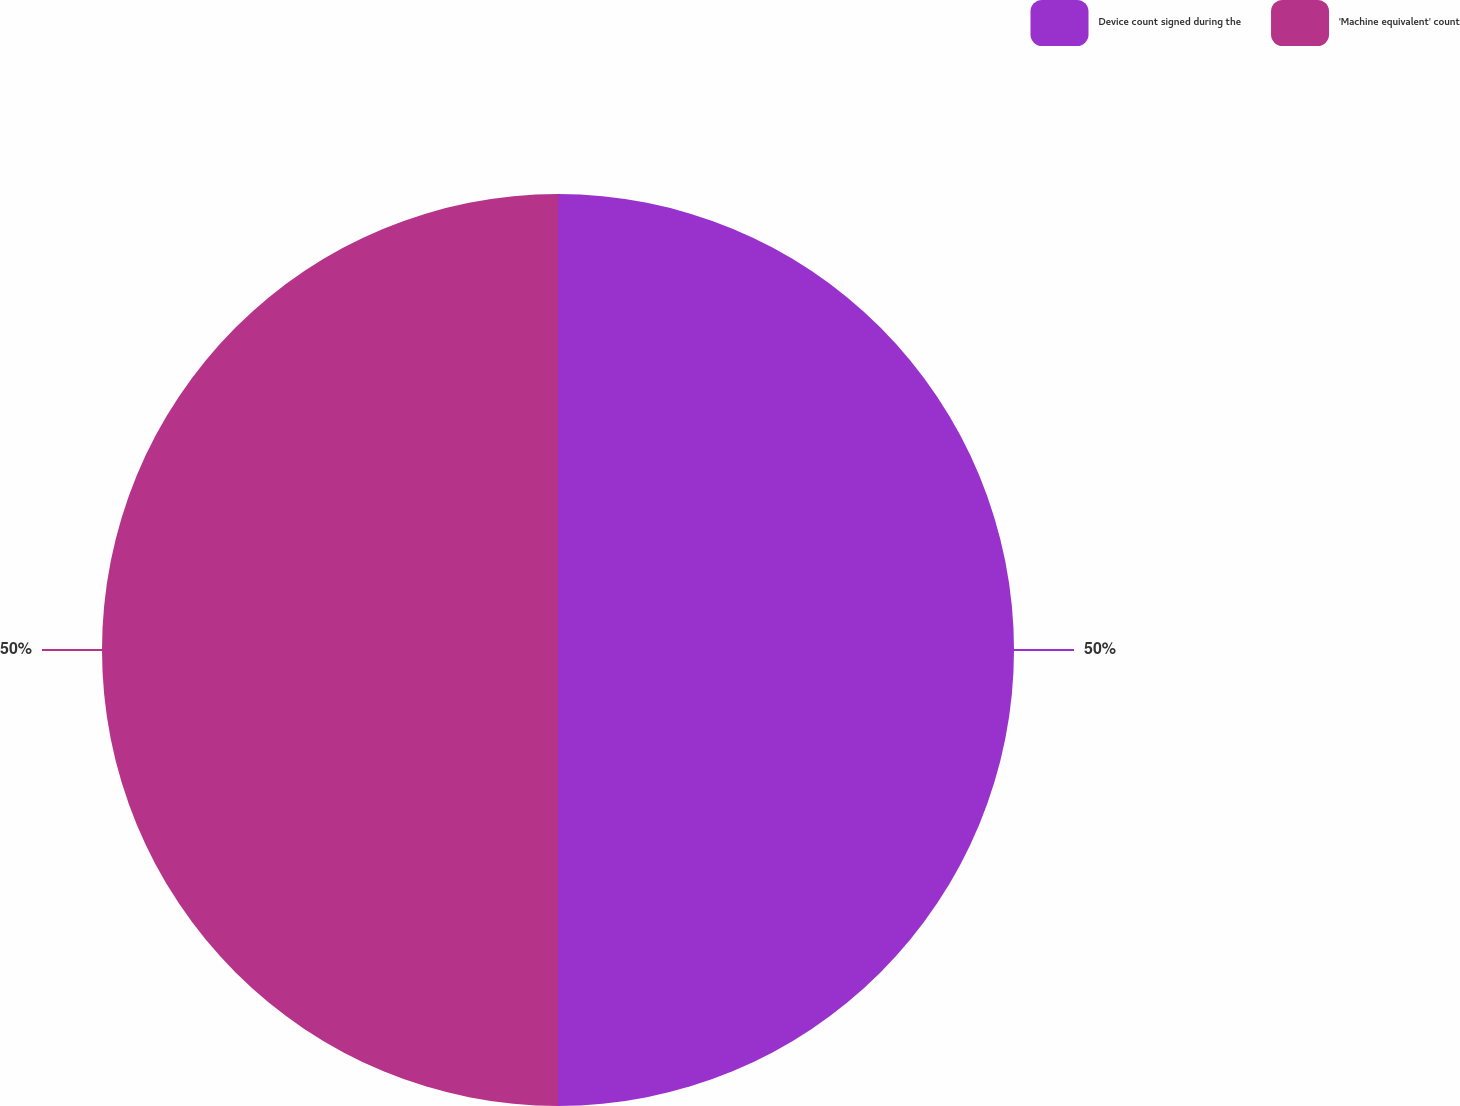Convert chart. <chart><loc_0><loc_0><loc_500><loc_500><pie_chart><fcel>Device count signed during the<fcel>'Machine equivalent' count<nl><fcel>50.0%<fcel>50.0%<nl></chart> 